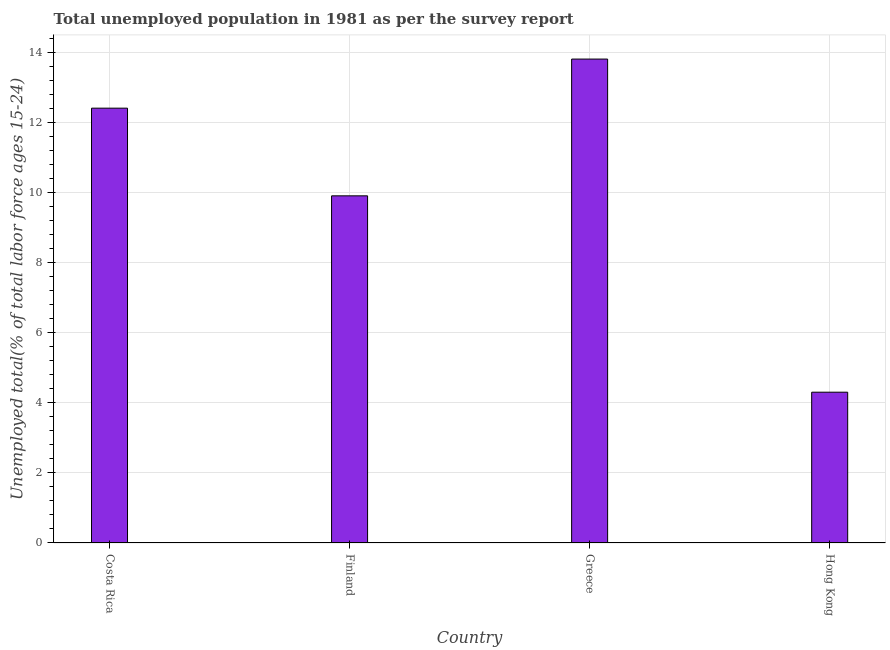Does the graph contain any zero values?
Give a very brief answer. No. What is the title of the graph?
Give a very brief answer. Total unemployed population in 1981 as per the survey report. What is the label or title of the X-axis?
Provide a short and direct response. Country. What is the label or title of the Y-axis?
Your response must be concise. Unemployed total(% of total labor force ages 15-24). What is the unemployed youth in Greece?
Offer a terse response. 13.8. Across all countries, what is the maximum unemployed youth?
Give a very brief answer. 13.8. Across all countries, what is the minimum unemployed youth?
Provide a succinct answer. 4.3. In which country was the unemployed youth maximum?
Your answer should be very brief. Greece. In which country was the unemployed youth minimum?
Offer a terse response. Hong Kong. What is the sum of the unemployed youth?
Your answer should be compact. 40.4. What is the difference between the unemployed youth in Costa Rica and Finland?
Give a very brief answer. 2.5. What is the average unemployed youth per country?
Give a very brief answer. 10.1. What is the median unemployed youth?
Keep it short and to the point. 11.15. What is the ratio of the unemployed youth in Costa Rica to that in Hong Kong?
Offer a terse response. 2.88. Is the unemployed youth in Finland less than that in Greece?
Ensure brevity in your answer.  Yes. Is the difference between the unemployed youth in Costa Rica and Hong Kong greater than the difference between any two countries?
Provide a succinct answer. No. What is the difference between the highest and the second highest unemployed youth?
Your answer should be compact. 1.4. Are all the bars in the graph horizontal?
Your response must be concise. No. How many countries are there in the graph?
Your answer should be compact. 4. Are the values on the major ticks of Y-axis written in scientific E-notation?
Provide a short and direct response. No. What is the Unemployed total(% of total labor force ages 15-24) of Costa Rica?
Offer a very short reply. 12.4. What is the Unemployed total(% of total labor force ages 15-24) of Finland?
Keep it short and to the point. 9.9. What is the Unemployed total(% of total labor force ages 15-24) of Greece?
Offer a very short reply. 13.8. What is the Unemployed total(% of total labor force ages 15-24) of Hong Kong?
Give a very brief answer. 4.3. What is the difference between the Unemployed total(% of total labor force ages 15-24) in Costa Rica and Greece?
Give a very brief answer. -1.4. What is the difference between the Unemployed total(% of total labor force ages 15-24) in Finland and Greece?
Keep it short and to the point. -3.9. What is the difference between the Unemployed total(% of total labor force ages 15-24) in Finland and Hong Kong?
Offer a terse response. 5.6. What is the difference between the Unemployed total(% of total labor force ages 15-24) in Greece and Hong Kong?
Ensure brevity in your answer.  9.5. What is the ratio of the Unemployed total(% of total labor force ages 15-24) in Costa Rica to that in Finland?
Offer a terse response. 1.25. What is the ratio of the Unemployed total(% of total labor force ages 15-24) in Costa Rica to that in Greece?
Offer a very short reply. 0.9. What is the ratio of the Unemployed total(% of total labor force ages 15-24) in Costa Rica to that in Hong Kong?
Ensure brevity in your answer.  2.88. What is the ratio of the Unemployed total(% of total labor force ages 15-24) in Finland to that in Greece?
Offer a terse response. 0.72. What is the ratio of the Unemployed total(% of total labor force ages 15-24) in Finland to that in Hong Kong?
Your answer should be compact. 2.3. What is the ratio of the Unemployed total(% of total labor force ages 15-24) in Greece to that in Hong Kong?
Offer a terse response. 3.21. 